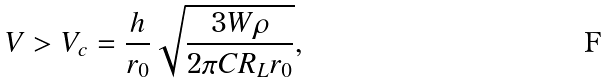Convert formula to latex. <formula><loc_0><loc_0><loc_500><loc_500>V > V _ { c } = \frac { h } { r _ { 0 } } \sqrt { \frac { 3 W \rho } { 2 \pi C R _ { L } r _ { 0 } } } ,</formula> 